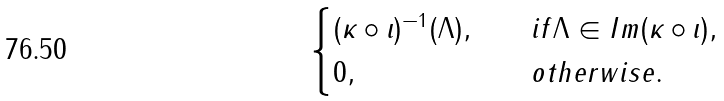Convert formula to latex. <formula><loc_0><loc_0><loc_500><loc_500>\begin{cases} ( \kappa \circ \iota ) ^ { - 1 } ( \Lambda ) , \quad & i f \Lambda \in I m ( \kappa \circ \iota ) , \\ 0 , & o t h e r w i s e . \end{cases}</formula> 